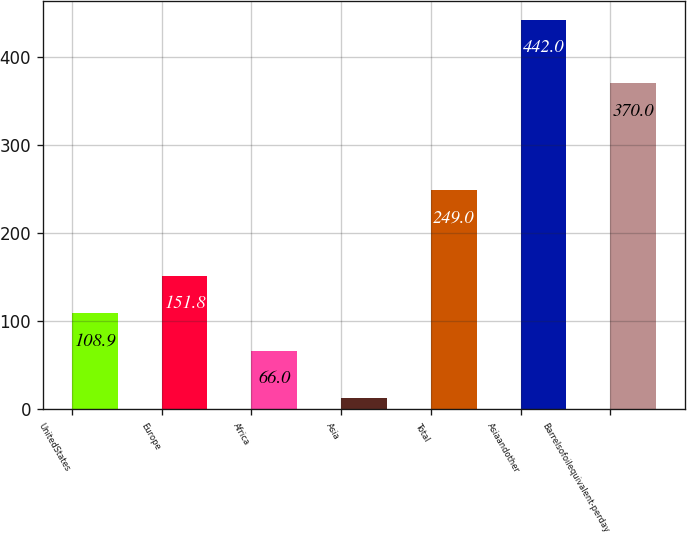Convert chart. <chart><loc_0><loc_0><loc_500><loc_500><bar_chart><fcel>UnitedStates<fcel>Europe<fcel>Africa<fcel>Asia<fcel>Total<fcel>Asiaandother<fcel>Barrelsofoilequivalent-perday<nl><fcel>108.9<fcel>151.8<fcel>66<fcel>13<fcel>249<fcel>442<fcel>370<nl></chart> 